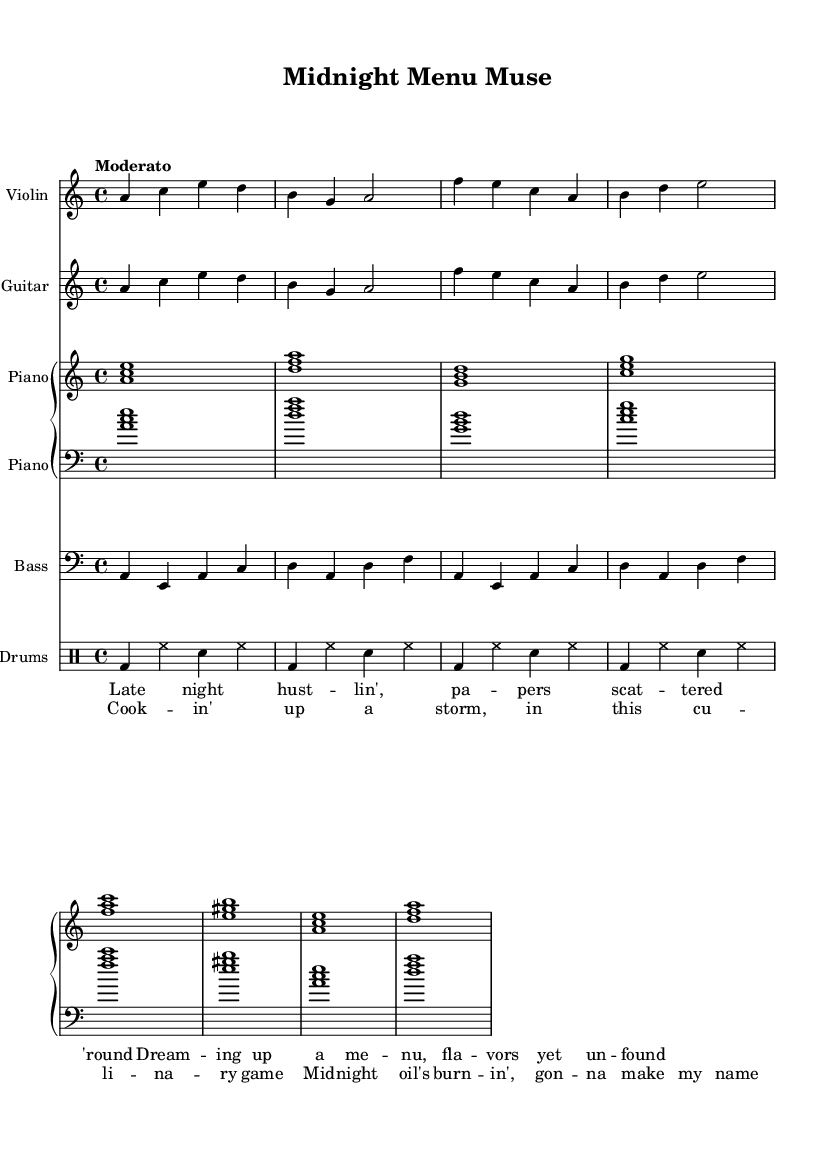What is the key signature of this music? The key signature is A minor, which has no sharps or flats and is indicated by the presence of the A note as the tonic in the provided parts.
Answer: A minor What is the time signature of the piece? The time signature is indicated as 4/4 at the beginning of the score, which means there are four beats in each measure and the quarter note gets one beat.
Answer: 4/4 What is the tempo marking for this music? The tempo marking is "Moderato," which suggests a moderate pace for the piece. This is explicitly stated above the score.
Answer: Moderato Which instrument has a bass clef? The staff labeled "Bass" is written in bass clef, indicating that it is typically used for lower-pitched instruments. This is evident in the clef symbol at the beginning of the bass staff.
Answer: Bass How many measures are there in the violin part? The violin part contains four measures which can be counted by identifying the distinct groupings of notes divided by vertical lines in the staff.
Answer: Four What type of musical piece is this? This piece is categorized as Electric Blues, showcasing characteristics like the use of electric guitar, a steady rhythm, and a jazzy twist in its composition, especially seen in the improvisatory nature of the solos.
Answer: Electric Blues What lyrical theme is explored in the song? The lyrics reflect a culinary venture theme, with references to late-night planning and dreaming of flavors, as illustrated in the verses which focus on aspirations associated with cooking.
Answer: Culinary venture 